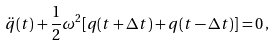<formula> <loc_0><loc_0><loc_500><loc_500>\ddot { q } ( t ) + \frac { 1 } { 2 } \omega ^ { 2 } [ q ( t + { \Delta t } ) + q ( t - { \Delta t } ) ] = 0 \, ,</formula> 